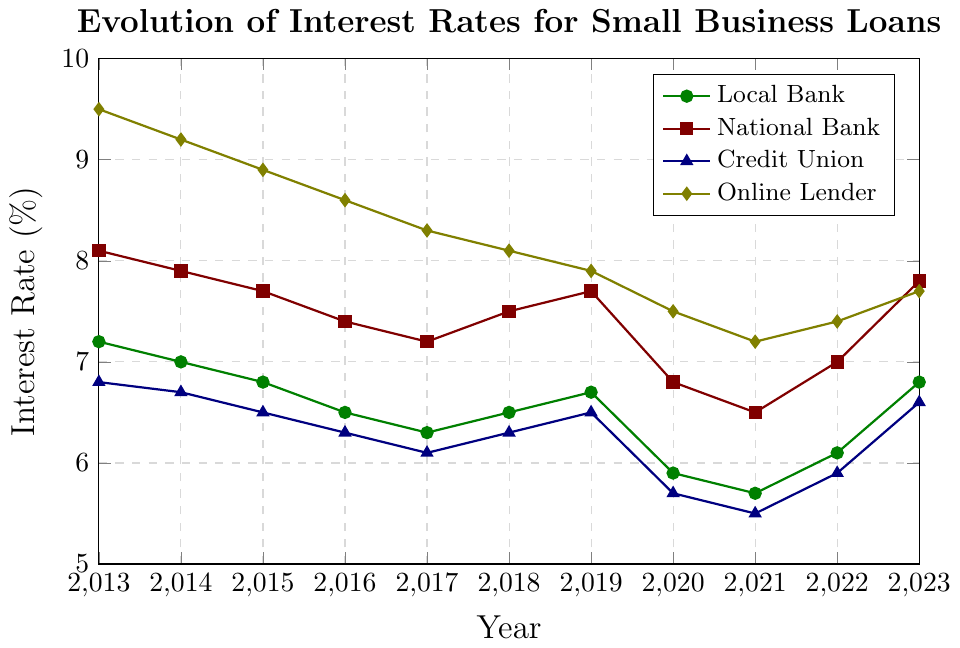what is the overall trend for the interest rates of local banks over the decade? By observing the line for Local Bank on the figure, it shows a decrease from 7.2% in 2013 to 5.7% in 2021, followed by a slight increase up to 6.8% in 2023.
Answer: decreasing, then slightly increasing how do the interest rates compare between the national bank and credit union in 2023? In 2023, the interest rate for the National Bank is 7.8%, while for the Credit Union, it is 6.6%. By comparing these values visually, we see that the National Bank's rate is higher.
Answer: national bank higher which lender had the highest interest rate in 2016? Looking at the figure for 2016, the highest point is marked by the Online Lender at 8.6%.
Answer: online lender what is the difference between the highest and lowest interest rates in 2020? In 2020, the highest interest rate is for the Online Lender at 7.5%, and the lowest is for the Credit Union at 5.7%. The difference can be calculated as 7.5% - 5.7% = 1.8%.
Answer: 1.8% which lender had the most stable interest rates throughout the decade? By comparing the lines for all lenders, the Credit Union’s trend line appears to be the most stable due to its smaller fluctuations in interest rates over the decade.
Answer: credit union what years did local banks experience an increase in interest rates? The Local Bank's interest rates increased from 6.3% in 2017 to 6.5% in 2018, again from 5.7% in 2021 to 6.1% in 2022, and from 6.1% in 2022 to 6.8% in 2023.
Answer: 2018, 2022, 2023 in which year was the gap between national bank and online lender interest rates the smallest? By comparing the lines for the National Bank and Online Lender, the smallest gap visibly appears in 2023 where the National Bank is at 7.8% and the Online Lender is at 7.7%. The gap is 0.1%.
Answer: 2023 what is the average interest rate for the credit union over the years 2013 to 2023? Summing the rates for the Credit Union: 6.8 + 6.7 + 6.5 + 6.3 + 6.1 + 6.3 + 6.5 + 5.7 + 5.5 + 5.9 + 6.6 = 69.9, then dividing by the number of years (11) gives an average of 69.9/11 = ~6.35%.
Answer: 6.35% what significant change did online lenders experience in 2019? The Online Lender’s interest rate dropped from 8.1% in 2018 to 7.9% in 2019, marking its first drop below 8% within the decade.
Answer: dropped below 8% which lender(s) had a lower interest rate than the local bank in 2020? In 2020, the Local Bank interest rate was 5.9%. Both the National Bank at 6.8% and the Credit Union at 5.7% had different rates, but only the Credit Union had a lower rate at 5.7%.
Answer: credit union 